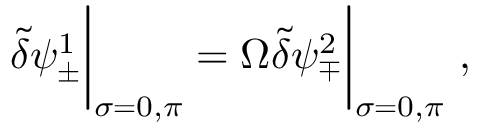Convert formula to latex. <formula><loc_0><loc_0><loc_500><loc_500>\tilde { \delta } \psi _ { \pm } ^ { 1 } \left | _ { \sigma = 0 , \pi } = \Omega \tilde { \delta } \psi _ { \mp } ^ { 2 } \right | _ { \sigma = 0 , \pi } ,</formula> 